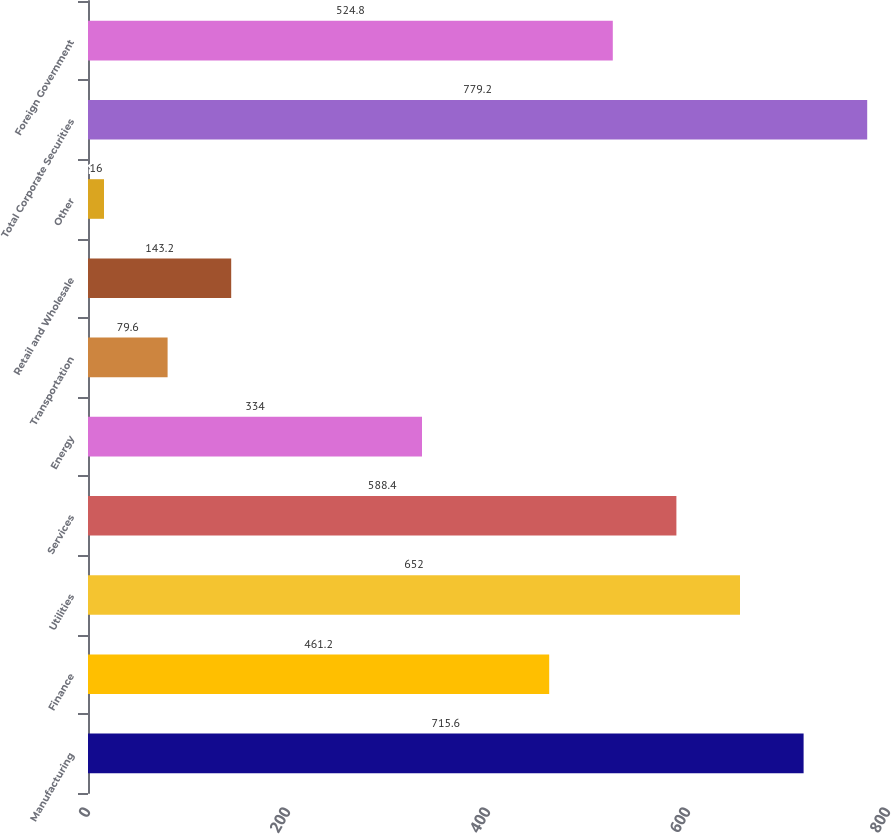Convert chart to OTSL. <chart><loc_0><loc_0><loc_500><loc_500><bar_chart><fcel>Manufacturing<fcel>Finance<fcel>Utilities<fcel>Services<fcel>Energy<fcel>Transportation<fcel>Retail and Wholesale<fcel>Other<fcel>Total Corporate Securities<fcel>Foreign Government<nl><fcel>715.6<fcel>461.2<fcel>652<fcel>588.4<fcel>334<fcel>79.6<fcel>143.2<fcel>16<fcel>779.2<fcel>524.8<nl></chart> 